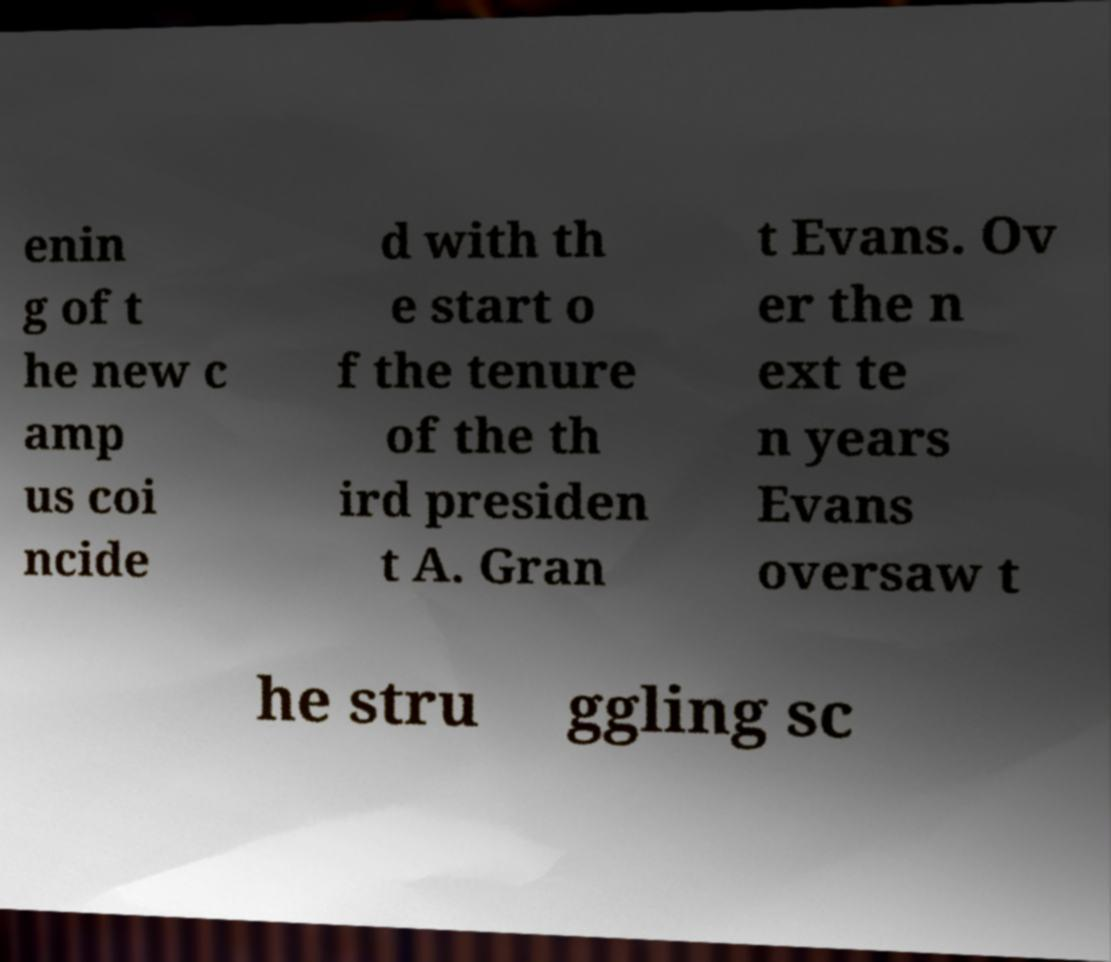What messages or text are displayed in this image? I need them in a readable, typed format. enin g of t he new c amp us coi ncide d with th e start o f the tenure of the th ird presiden t A. Gran t Evans. Ov er the n ext te n years Evans oversaw t he stru ggling sc 